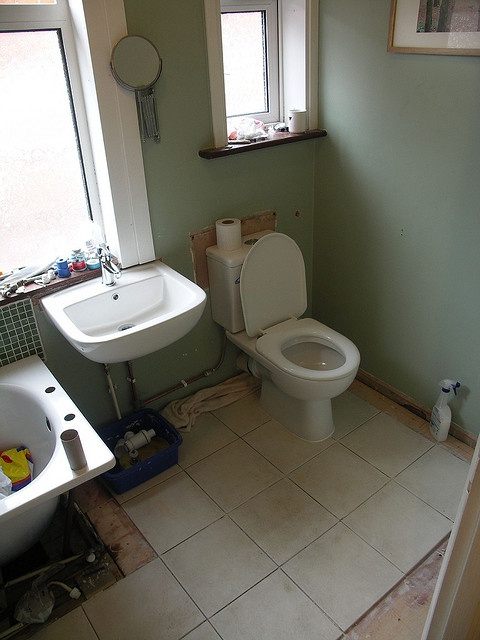Describe the objects in this image and their specific colors. I can see toilet in tan, gray, and black tones, sink in tan, lightgray, gray, darkgray, and black tones, and toothbrush in tan, lightgray, and darkgray tones in this image. 